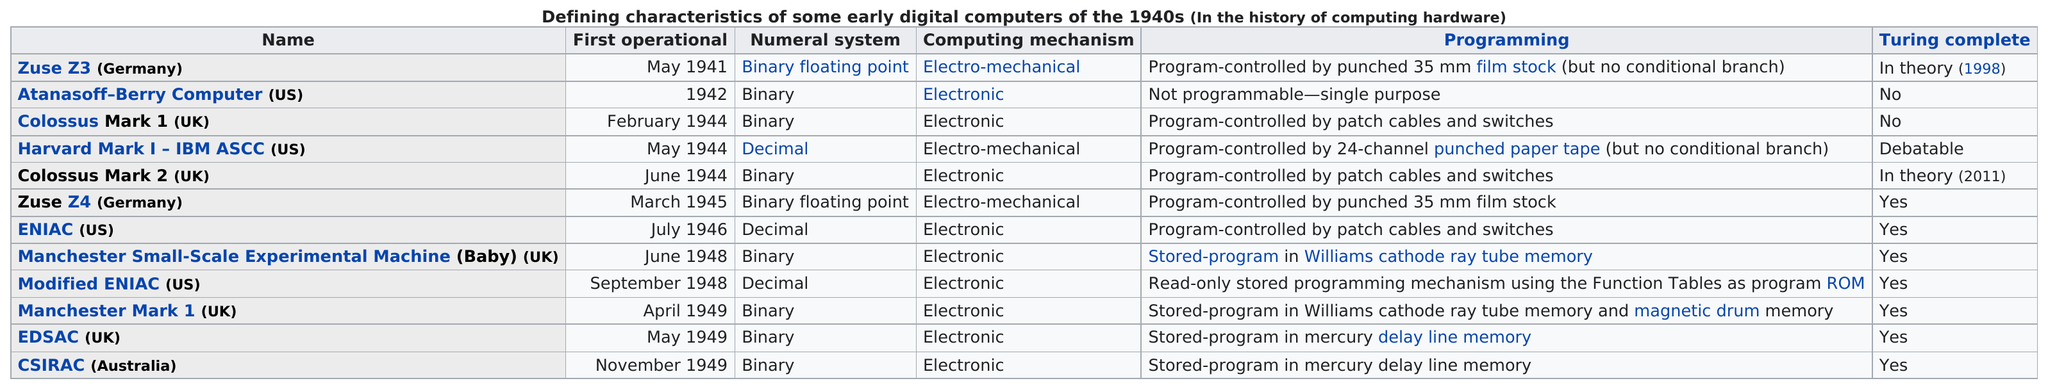Specify some key components in this picture. The Zuse Z3, a German computer built in 1941, had an operational date that was next to May 1941. The Z4 was the next computer after the Zuse Z3, and it was built by Konrad Zuse in Germany. After the Z4, the next computer was the ENIAC, which was built in the United States. Of the items listed on the chart, two of them have the label 'no' and are considered to be Turing complete. The Harvard Mark I was the first computer to use a decimal numeral system. It was developed in the 1940s by IBM and the Automatic Sequence Control Computer (ASCC) team, and was used for a variety of tasks including scientific calculations and ballistic missile guidance. The computer system known as the Colossus Mark 1, which was operated in the United Kingdom during May 1944, is the subject of this declaration. 